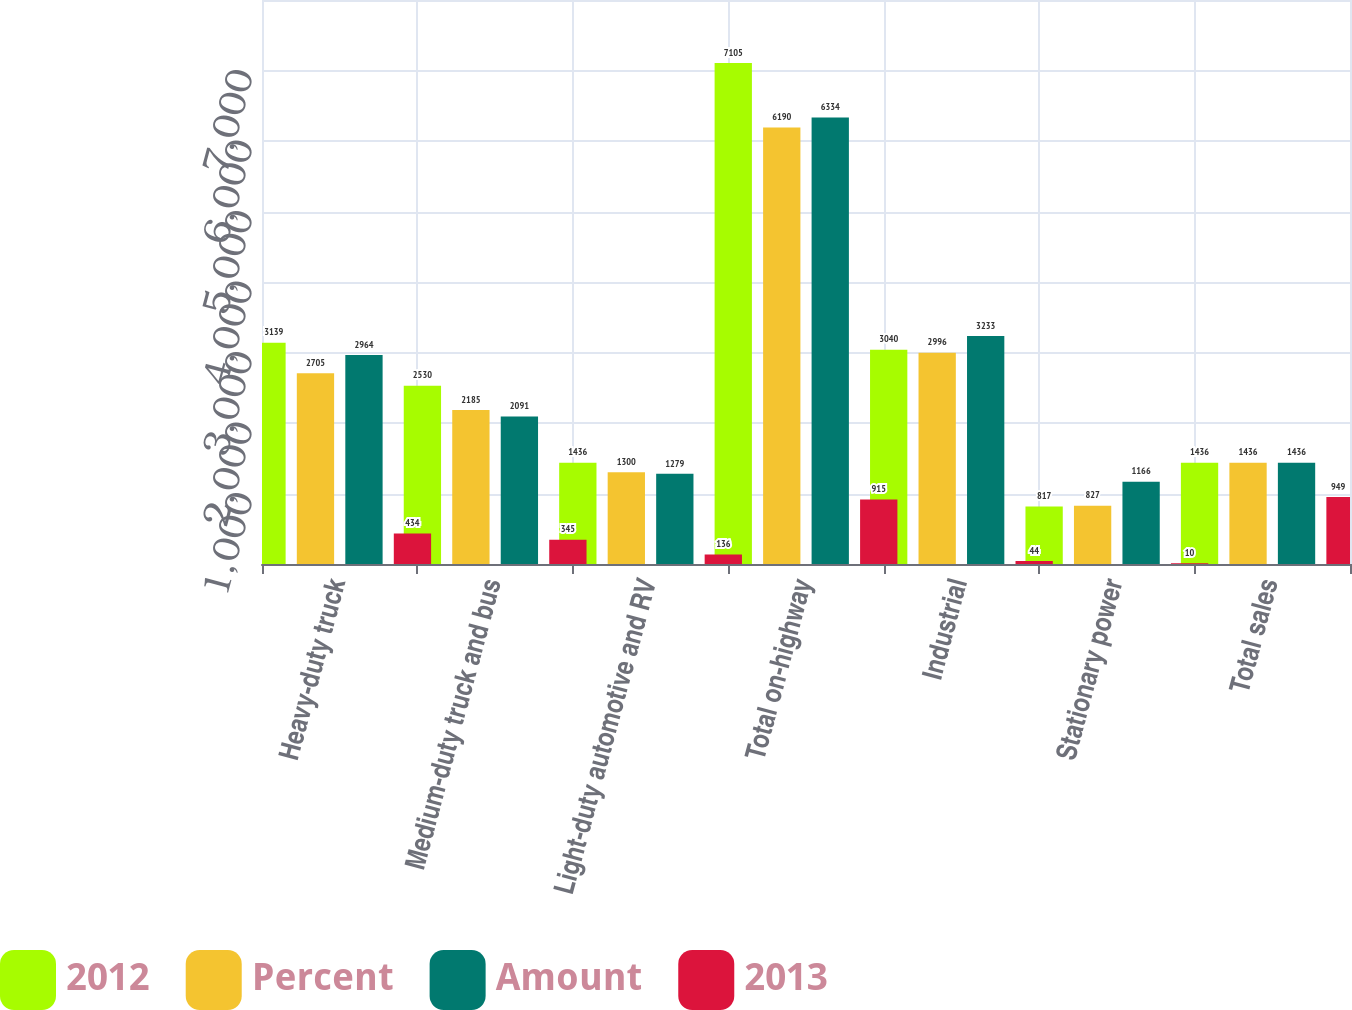Convert chart. <chart><loc_0><loc_0><loc_500><loc_500><stacked_bar_chart><ecel><fcel>Heavy-duty truck<fcel>Medium-duty truck and bus<fcel>Light-duty automotive and RV<fcel>Total on-highway<fcel>Industrial<fcel>Stationary power<fcel>Total sales<nl><fcel>2012<fcel>3139<fcel>2530<fcel>1436<fcel>7105<fcel>3040<fcel>817<fcel>1436<nl><fcel>Percent<fcel>2705<fcel>2185<fcel>1300<fcel>6190<fcel>2996<fcel>827<fcel>1436<nl><fcel>Amount<fcel>2964<fcel>2091<fcel>1279<fcel>6334<fcel>3233<fcel>1166<fcel>1436<nl><fcel>2013<fcel>434<fcel>345<fcel>136<fcel>915<fcel>44<fcel>10<fcel>949<nl></chart> 